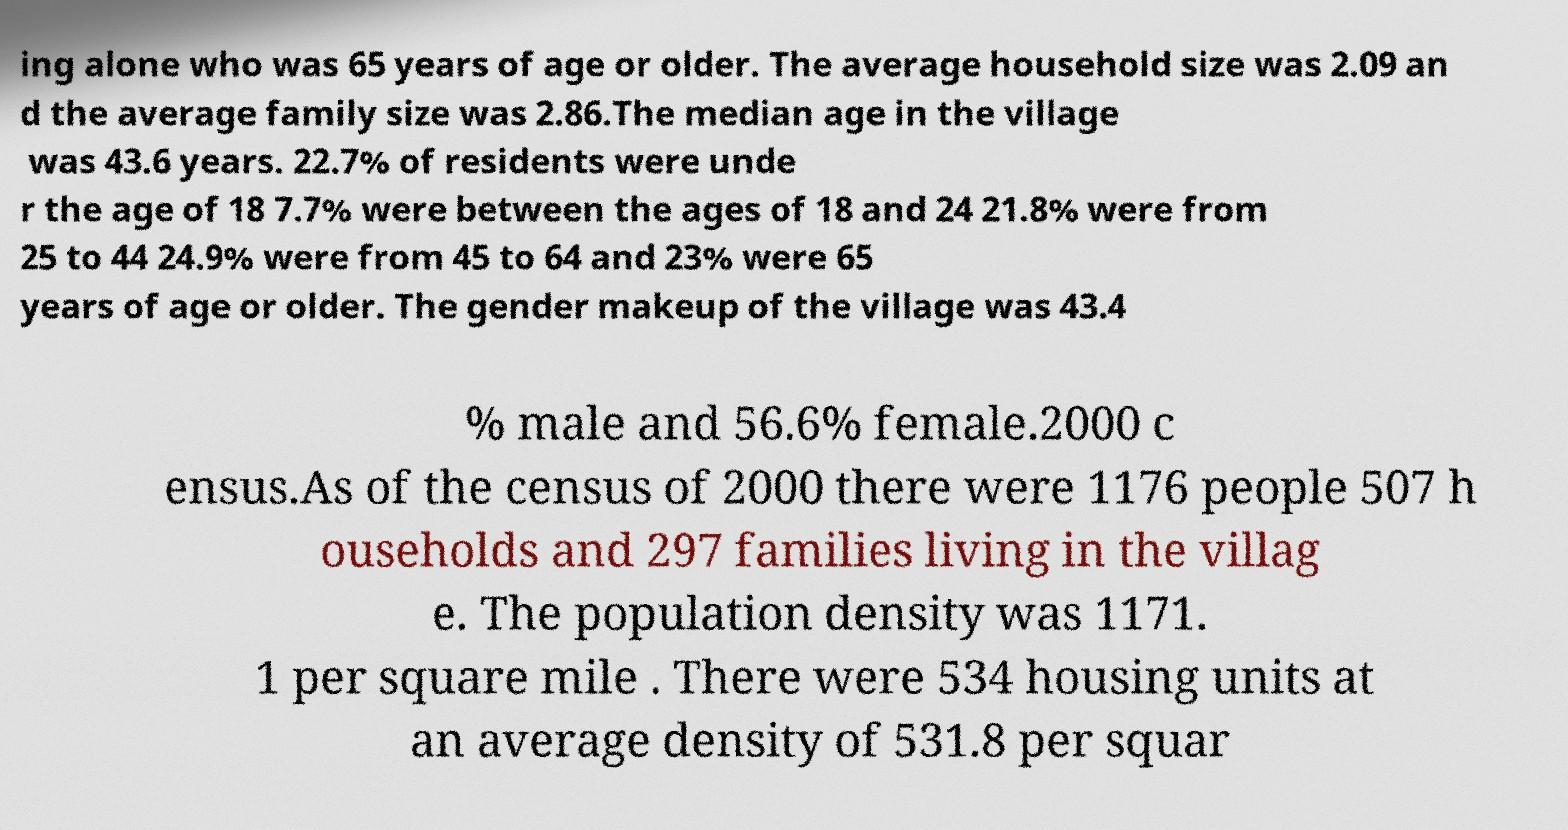What messages or text are displayed in this image? I need them in a readable, typed format. ing alone who was 65 years of age or older. The average household size was 2.09 an d the average family size was 2.86.The median age in the village was 43.6 years. 22.7% of residents were unde r the age of 18 7.7% were between the ages of 18 and 24 21.8% were from 25 to 44 24.9% were from 45 to 64 and 23% were 65 years of age or older. The gender makeup of the village was 43.4 % male and 56.6% female.2000 c ensus.As of the census of 2000 there were 1176 people 507 h ouseholds and 297 families living in the villag e. The population density was 1171. 1 per square mile . There were 534 housing units at an average density of 531.8 per squar 